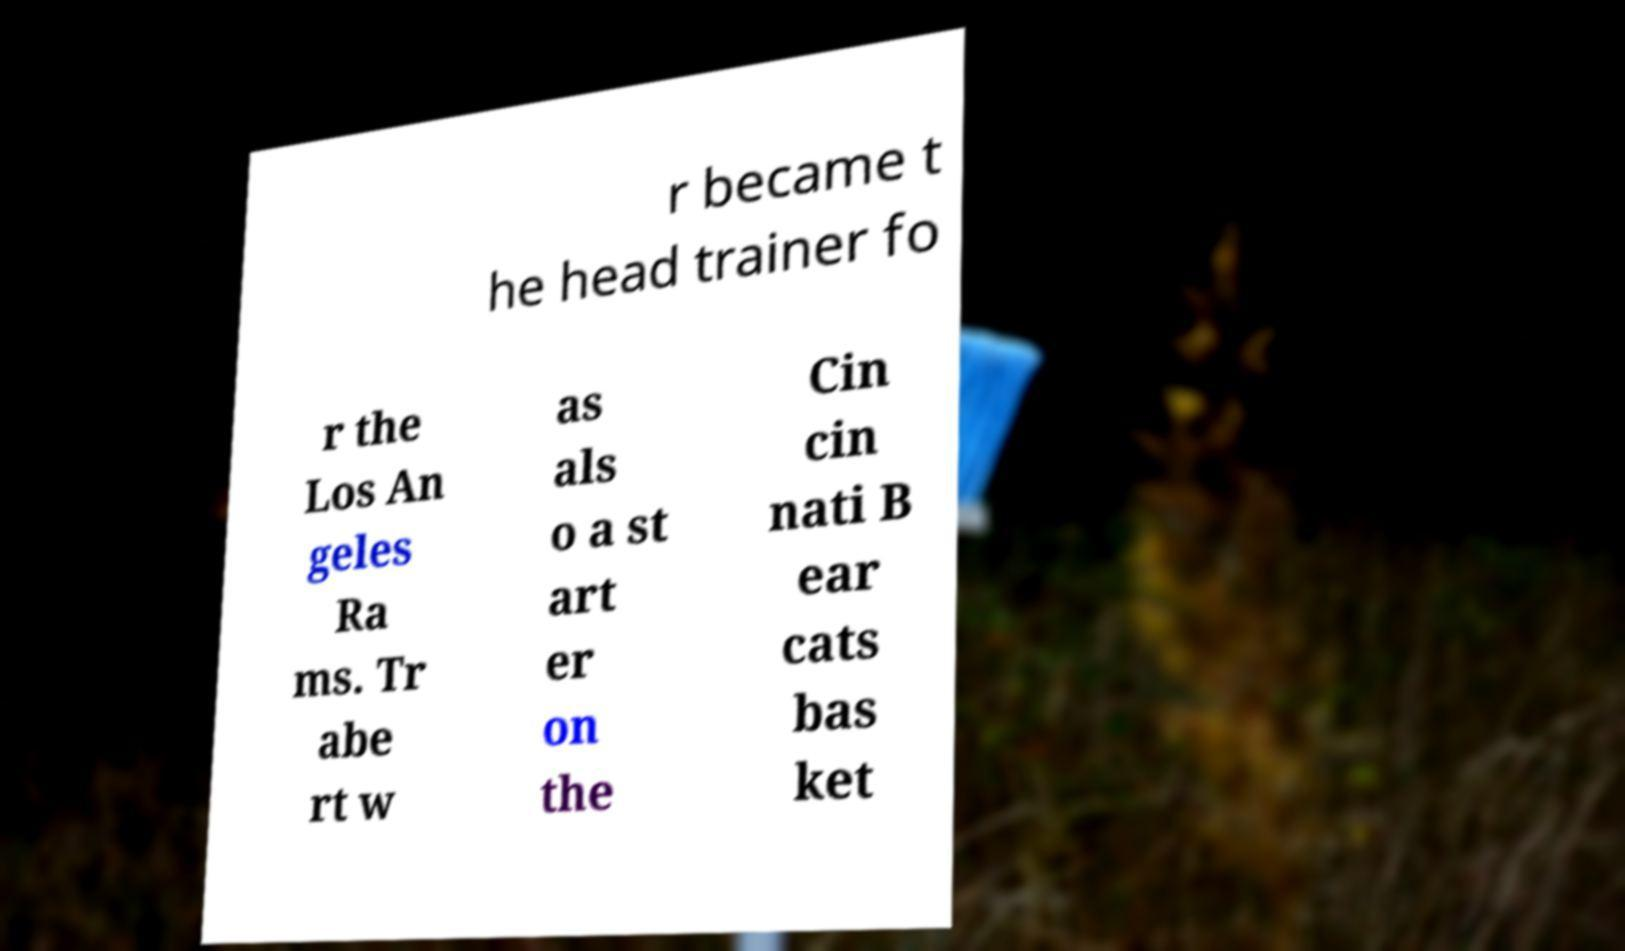There's text embedded in this image that I need extracted. Can you transcribe it verbatim? r became t he head trainer fo r the Los An geles Ra ms. Tr abe rt w as als o a st art er on the Cin cin nati B ear cats bas ket 